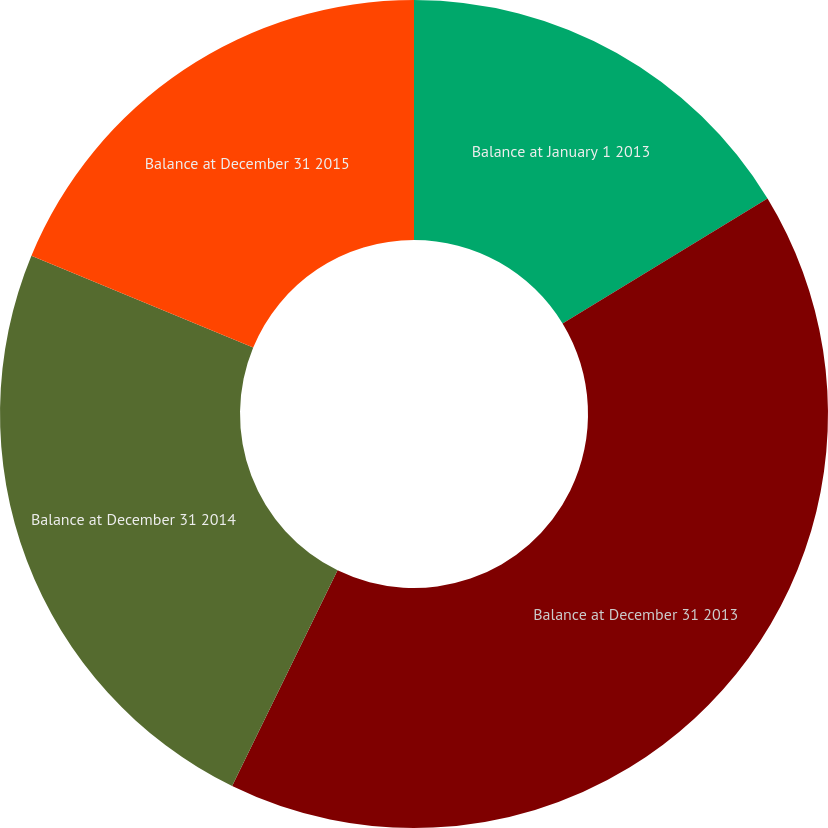Convert chart. <chart><loc_0><loc_0><loc_500><loc_500><pie_chart><fcel>Balance at January 1 2013<fcel>Balance at December 31 2013<fcel>Balance at December 31 2014<fcel>Balance at December 31 2015<nl><fcel>16.29%<fcel>40.95%<fcel>24.0%<fcel>18.76%<nl></chart> 